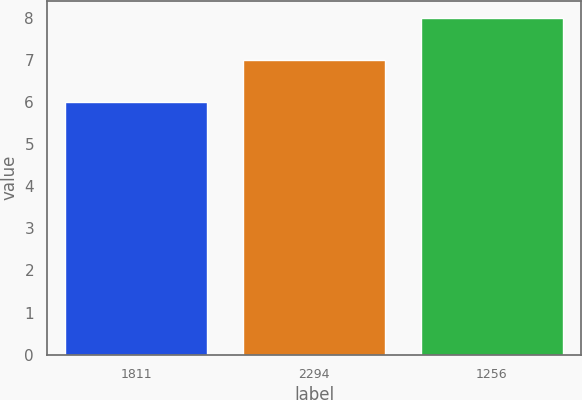<chart> <loc_0><loc_0><loc_500><loc_500><bar_chart><fcel>1811<fcel>2294<fcel>1256<nl><fcel>6<fcel>7<fcel>8<nl></chart> 